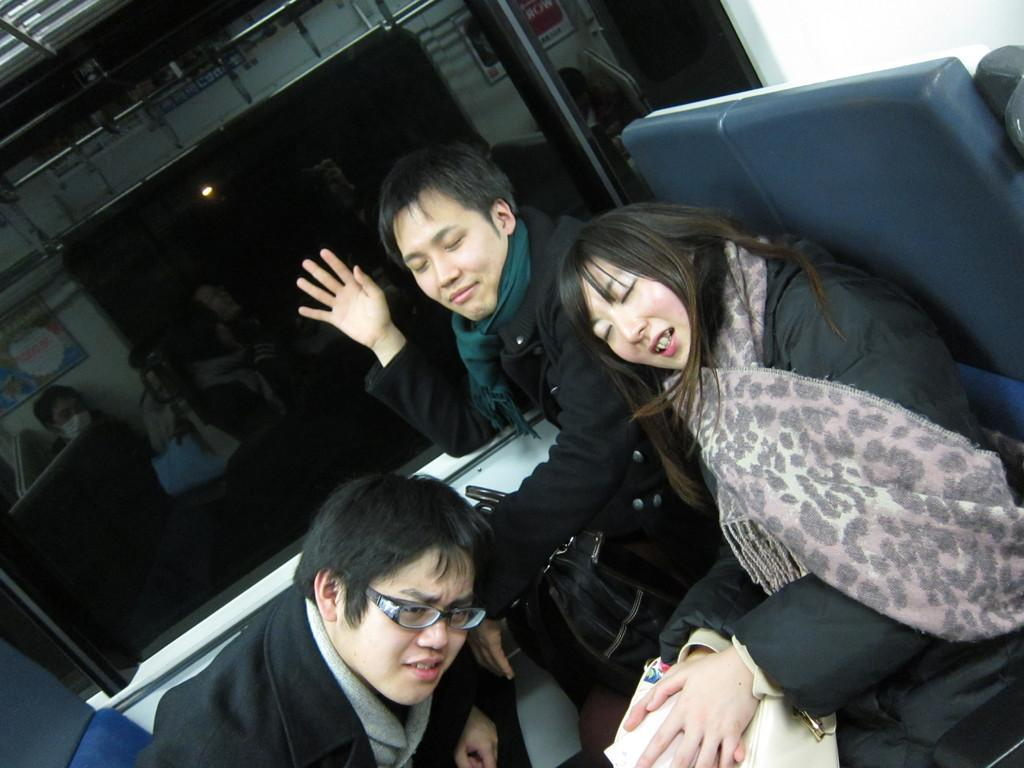What are the persons in the image doing? The persons in the image are sitting on chairs. Can you describe the setting of the image? There is a window visible in the background of the image. What type of string can be heard in the image? There is no string present in the image, and therefore no sound can be heard. 